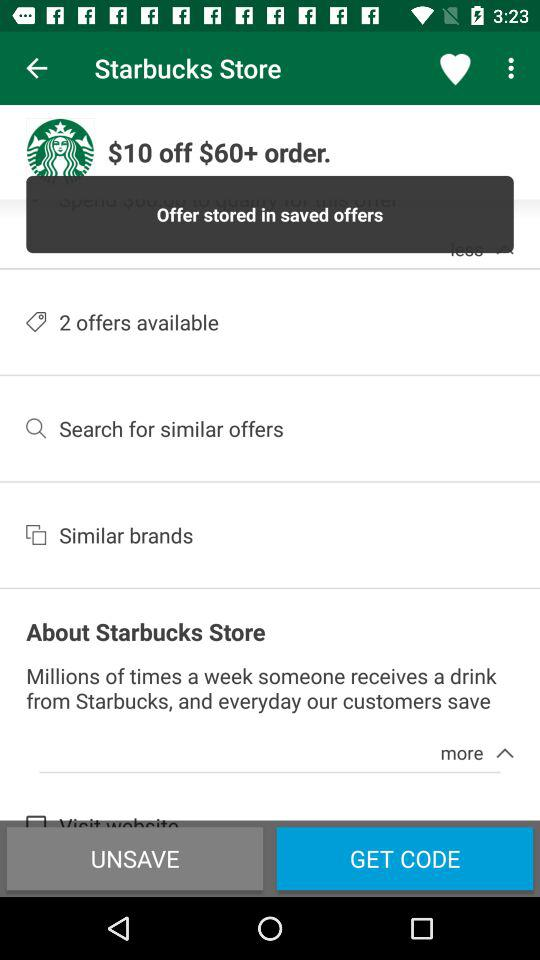How many offers are available at the Starbucks store? There are 2 offers available at the Starbucks store. 